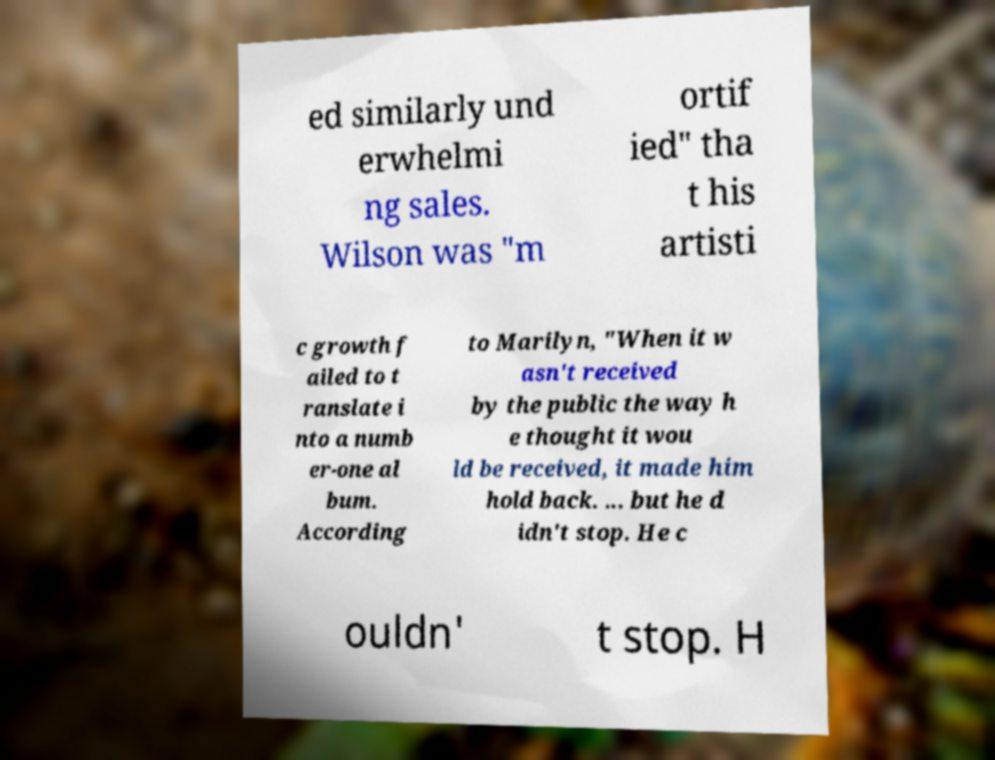Could you assist in decoding the text presented in this image and type it out clearly? ed similarly und erwhelmi ng sales. Wilson was "m ortif ied" tha t his artisti c growth f ailed to t ranslate i nto a numb er-one al bum. According to Marilyn, "When it w asn't received by the public the way h e thought it wou ld be received, it made him hold back. ... but he d idn't stop. He c ouldn' t stop. H 